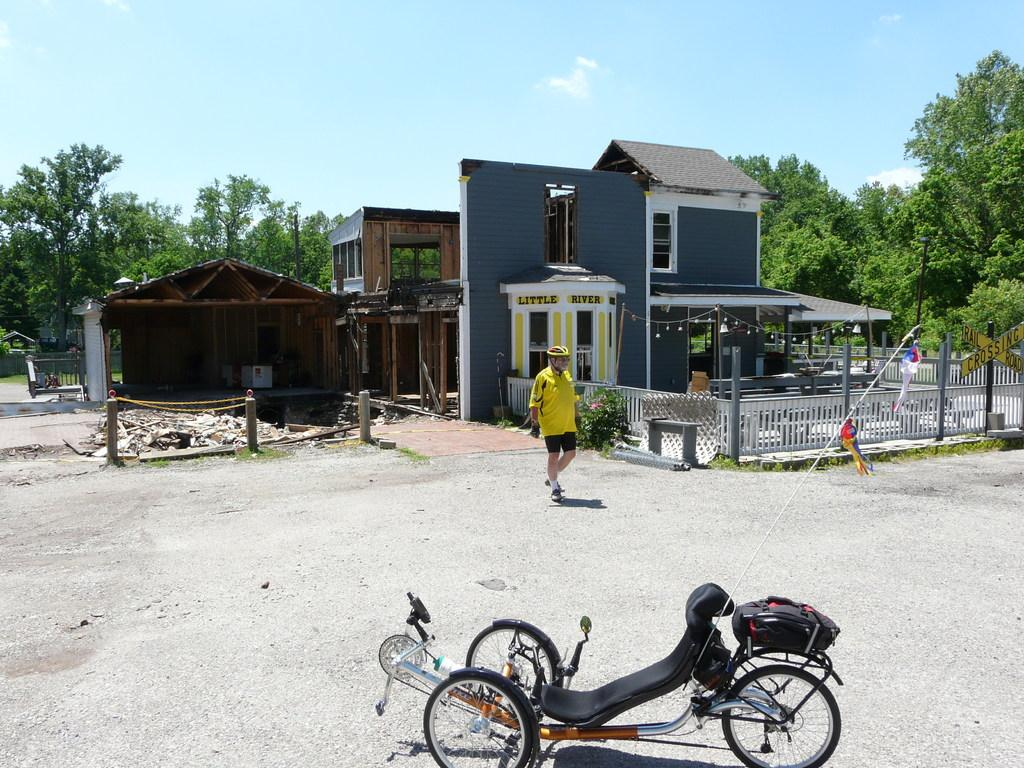Who is the main subject in the image? There is a man in the image. Where is the man located in the image? The man is in the middle of the image. What structure is near the man in the image? There is a house near the man in the image. What type of leather is the man wearing in the image? There is no mention of leather in the image, and the man's clothing cannot be determined from the provided facts. Are there any bears visible in the image? No, there are no bears present in the image. 